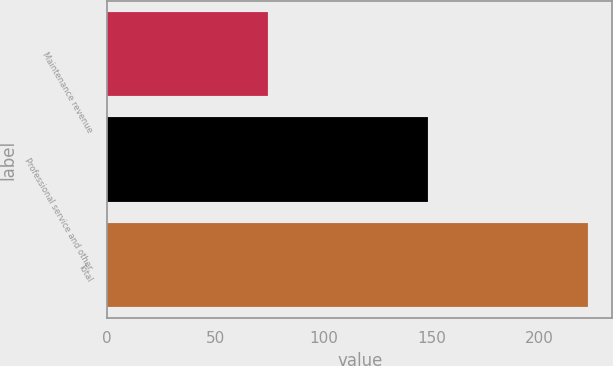Convert chart. <chart><loc_0><loc_0><loc_500><loc_500><bar_chart><fcel>Maintenance revenue<fcel>Professional service and other<fcel>Total<nl><fcel>74.3<fcel>148.3<fcel>222.6<nl></chart> 